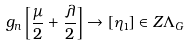<formula> <loc_0><loc_0><loc_500><loc_500>g _ { n } \left [ \frac { \mu } { 2 } + \frac { \lambda } { 2 } \right ] \to [ \eta _ { 1 } ] \in Z \Lambda _ { G }</formula> 